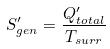Convert formula to latex. <formula><loc_0><loc_0><loc_500><loc_500>S _ { g e n } ^ { \prime } = \frac { Q _ { t o t a l } ^ { \prime } } { T _ { s u r r } }</formula> 